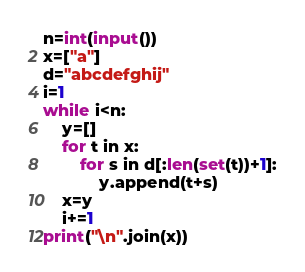Convert code to text. <code><loc_0><loc_0><loc_500><loc_500><_Python_>n=int(input())
x=["a"]
d="abcdefghij"
i=1
while i<n:
	y=[]
	for t in x:
		for s in d[:len(set(t))+1]:
			y.append(t+s)
	x=y
	i+=1
print("\n".join(x))</code> 